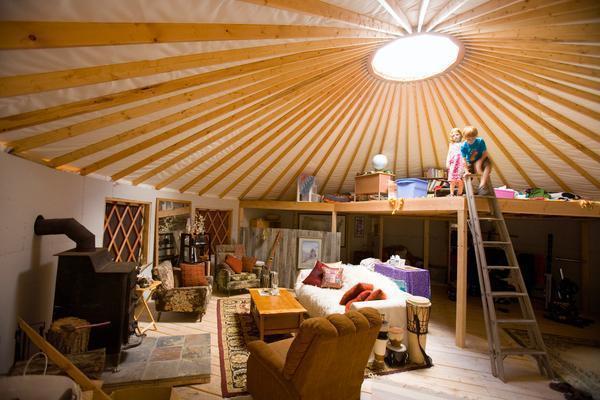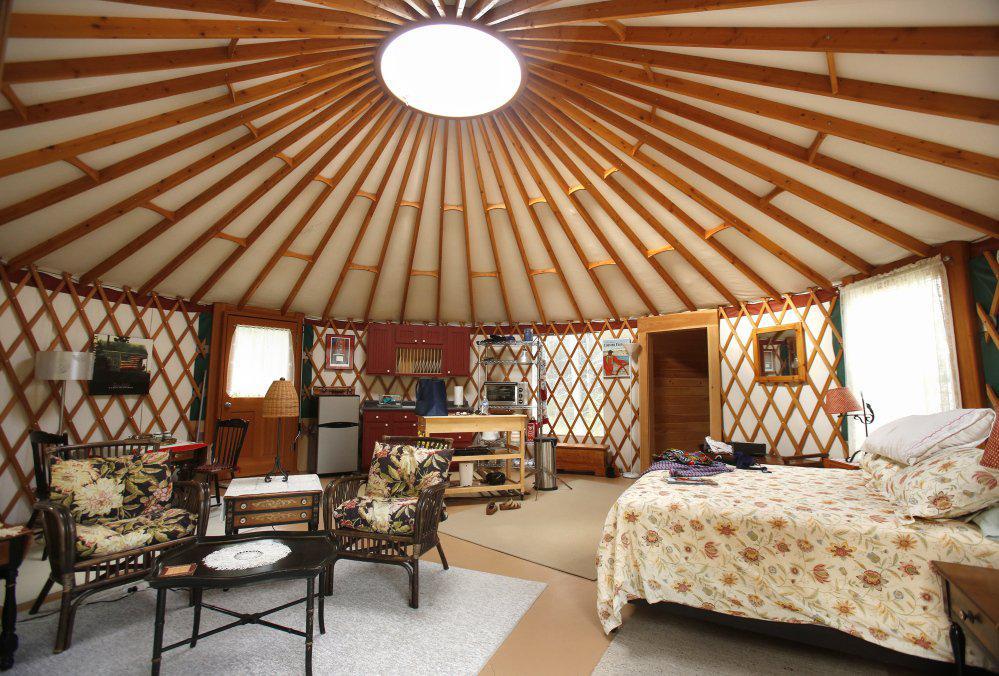The first image is the image on the left, the second image is the image on the right. Given the left and right images, does the statement "A ladder goes up to an upper area of the hut in one of the images." hold true? Answer yes or no. Yes. The first image is the image on the left, the second image is the image on the right. Assess this claim about the two images: "A ladder with rungs leads up to a loft area in at least one image.". Correct or not? Answer yes or no. Yes. 